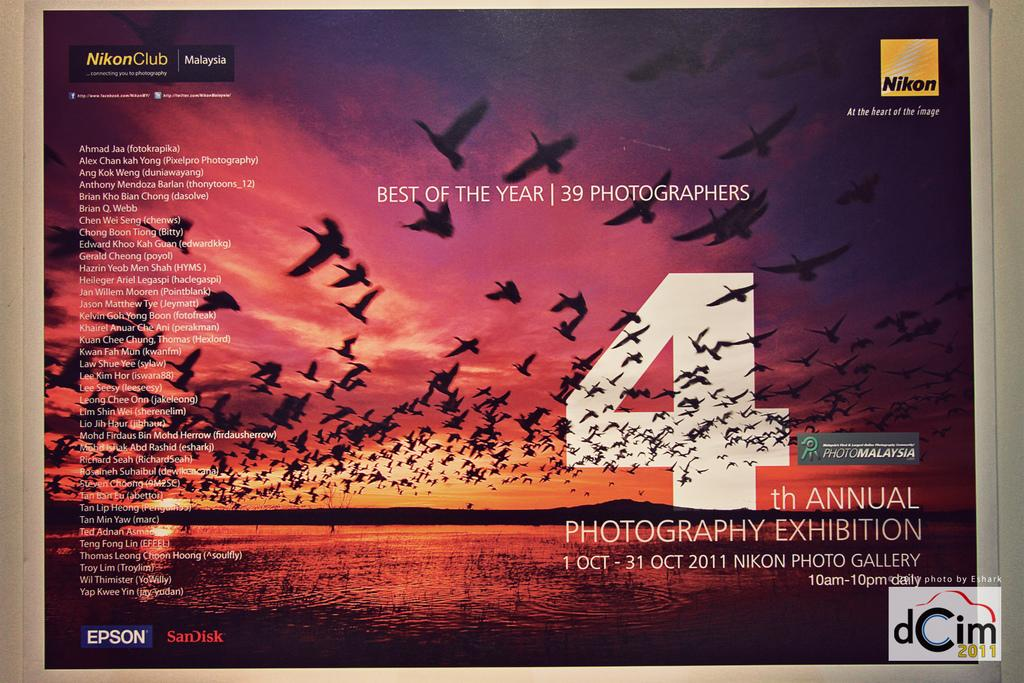<image>
Present a compact description of the photo's key features. An advertisement for the 4th Annual Photography Exhibition is shown. 